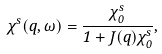<formula> <loc_0><loc_0><loc_500><loc_500>\chi ^ { s } ( q , \omega ) = \frac { \chi ^ { s } _ { 0 } } { 1 + J ( q ) \chi ^ { s } _ { 0 } } ,</formula> 